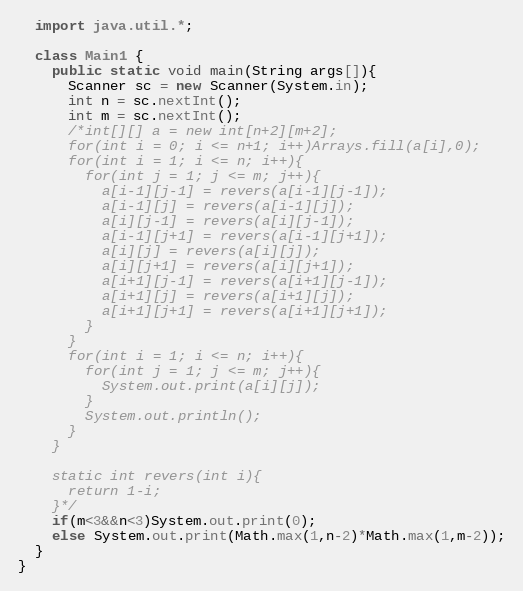Convert code to text. <code><loc_0><loc_0><loc_500><loc_500><_Java_>  import java.util.*;

  class Main1 {
    public static void main(String args[]){
      Scanner sc = new Scanner(System.in);
      int n = sc.nextInt();
      int m = sc.nextInt();
      /*int[][] a = new int[n+2][m+2];
      for(int i = 0; i <= n+1; i++)Arrays.fill(a[i],0);
      for(int i = 1; i <= n; i++){
        for(int j = 1; j <= m; j++){
          a[i-1][j-1] = revers(a[i-1][j-1]);
          a[i-1][j] = revers(a[i-1][j]);
          a[i][j-1] = revers(a[i][j-1]);
          a[i-1][j+1] = revers(a[i-1][j+1]);
          a[i][j] = revers(a[i][j]);
          a[i][j+1] = revers(a[i][j+1]);
          a[i+1][j-1] = revers(a[i+1][j-1]);
          a[i+1][j] = revers(a[i+1][j]);
          a[i+1][j+1] = revers(a[i+1][j+1]);
        }
      }
      for(int i = 1; i <= n; i++){
        for(int j = 1; j <= m; j++){
          System.out.print(a[i][j]);
        }
        System.out.println();
      }
    }

    static int revers(int i){
      return 1-i;
    }*/
    if(m<3&&n<3)System.out.print(0);
    else System.out.print(Math.max(1,n-2)*Math.max(1,m-2));
  }
}
</code> 